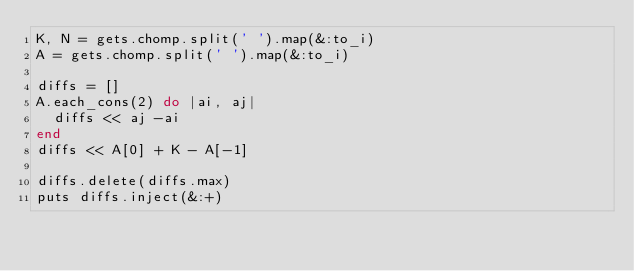Convert code to text. <code><loc_0><loc_0><loc_500><loc_500><_Ruby_>K, N = gets.chomp.split(' ').map(&:to_i)
A = gets.chomp.split(' ').map(&:to_i)

diffs = []
A.each_cons(2) do |ai, aj|
  diffs << aj -ai
end
diffs << A[0] + K - A[-1]

diffs.delete(diffs.max)
puts diffs.inject(&:+)
</code> 